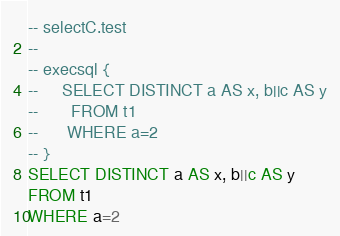Convert code to text. <code><loc_0><loc_0><loc_500><loc_500><_SQL_>-- selectC.test
-- 
-- execsql {
--     SELECT DISTINCT a AS x, b||c AS y
--       FROM t1
--      WHERE a=2
-- }
SELECT DISTINCT a AS x, b||c AS y
FROM t1
WHERE a=2</code> 